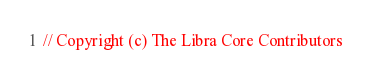Convert code to text. <code><loc_0><loc_0><loc_500><loc_500><_Rust_>// Copyright (c) The Libra Core Contributors</code> 